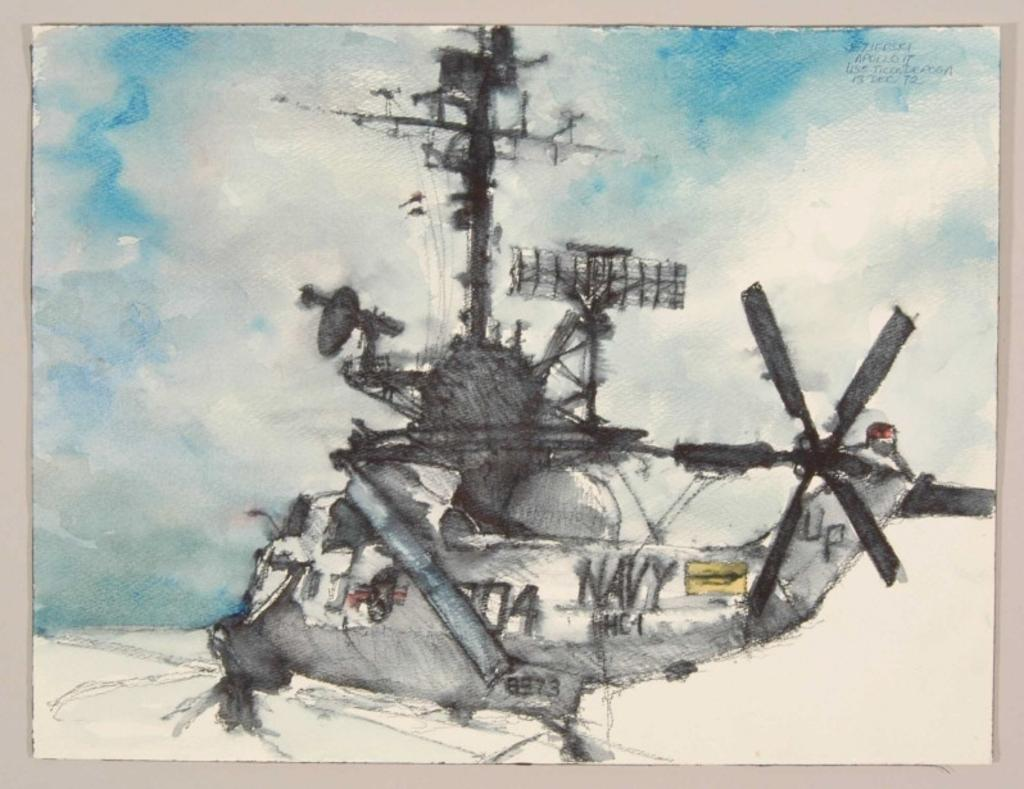<image>
Offer a succinct explanation of the picture presented. A grey Navy helicopter with UP on the tail 